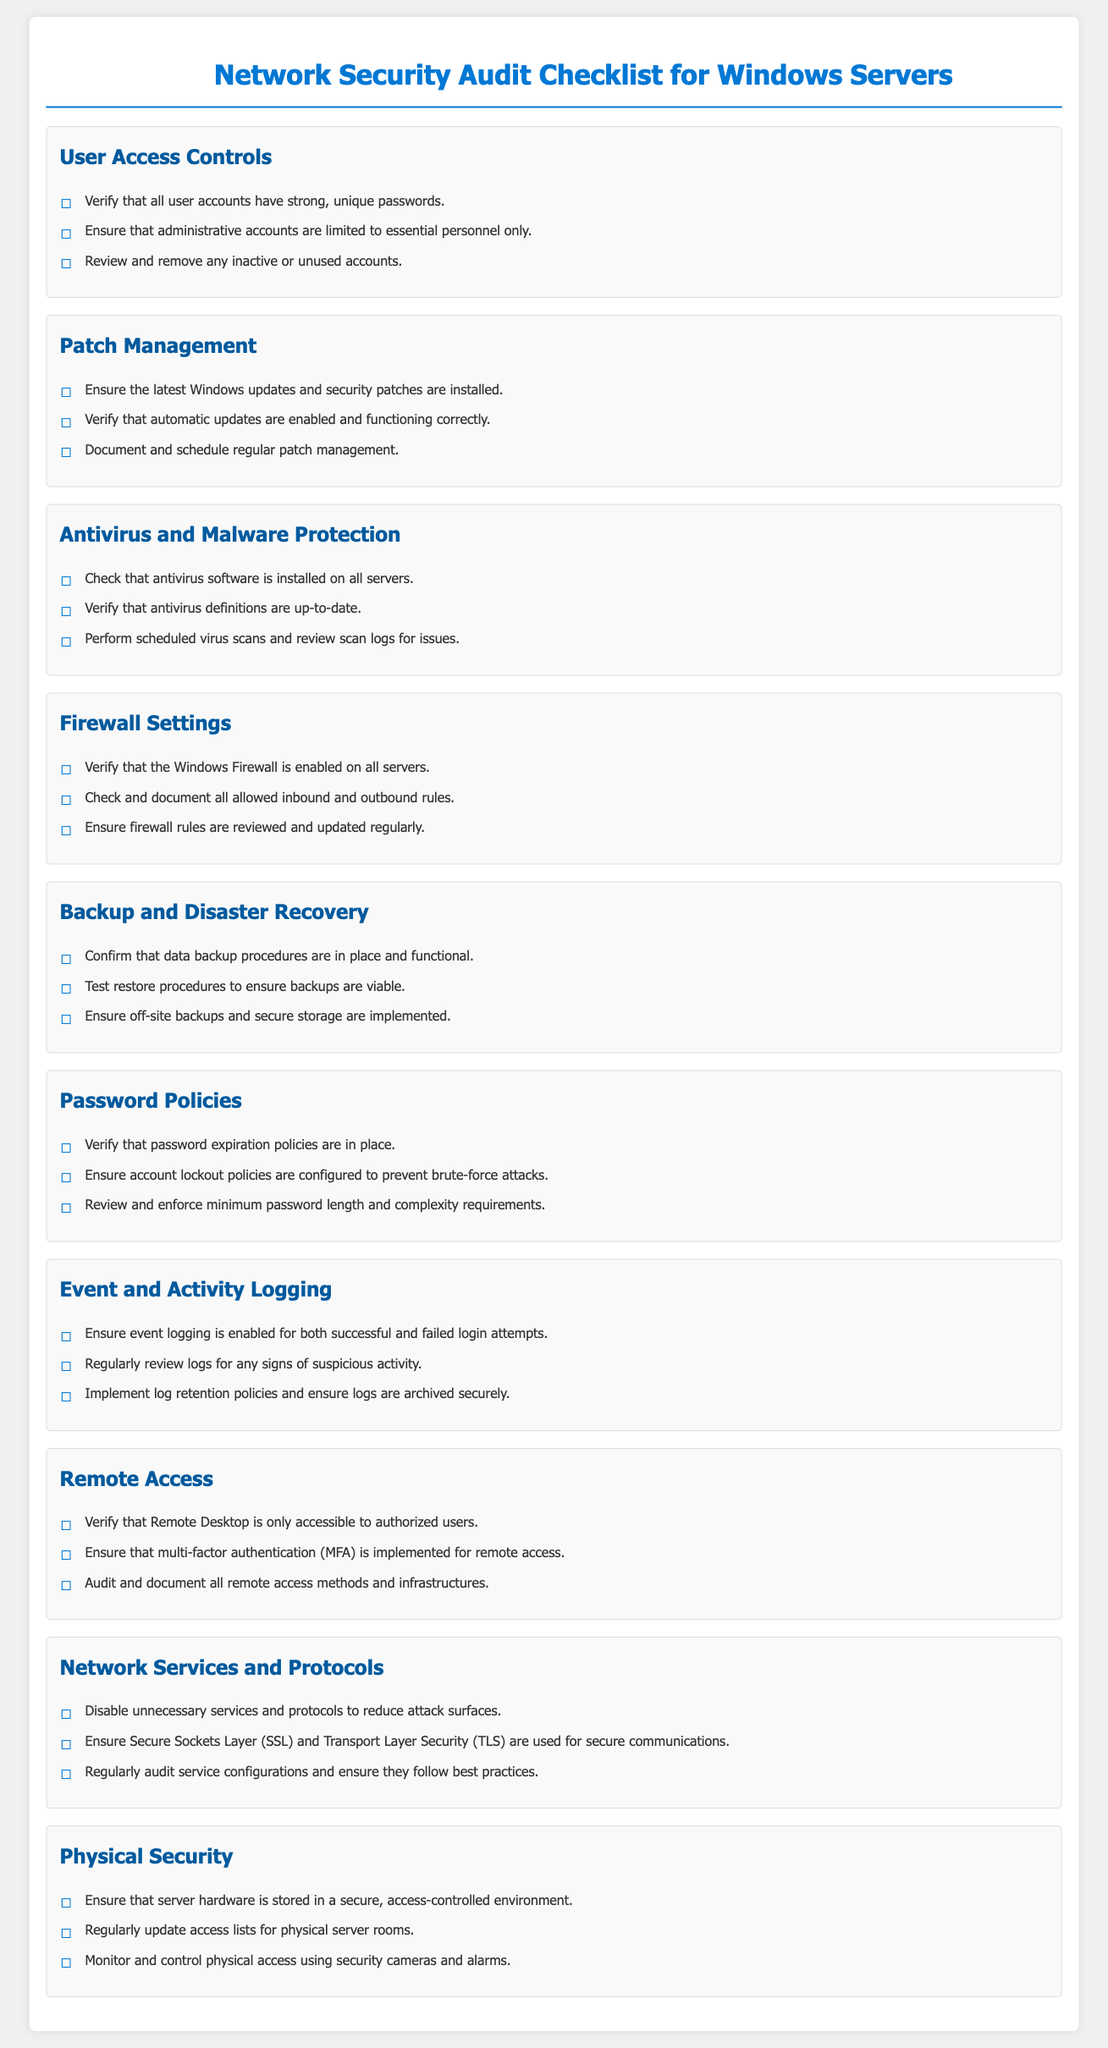What is the title of the document? The title of the document is located at the top of the rendered document, which identifies its purpose.
Answer: Network Security Audit Checklist for Windows Servers How many sections are listed in the document? The total count of distinct sections present in the document indicates the various aspects covered.
Answer: 10 What is one of the requirements for user access controls? The specific requirements for user access controls are contained within the subsection details.
Answer: Strong, unique passwords What must be verified for antivirus and malware protection? This relates to the specific checks required for antivirus implementation mentioned in the relevant section.
Answer: Antivirus definitions are up-to-date What is one action to take for backup and disaster recovery? The actions related to data backup policies can be found within that specific section.
Answer: Test restore procedures What is emphasized for remote access? This question relates to the security measures needed when allowing remote access according to the checklist.
Answer: Multi-factor authentication How often should firewall rules be reviewed? The requirement regarding the frequency of firewall rule updates is mentioned in the firewall settings section.
Answer: Regularly Where should server hardware be stored according to physical security measures? The details regarding the physical security of server locations can be found in that respective section.
Answer: Secure, access-controlled environment What should event logging capture according to the checklist? The details on logging requirements can be found in the specified section on event and activity logging.
Answer: Successful and failed login attempts What type of services should be disabled to enhance security? The guidelines for network services are indicated in the section dedicated to network services and protocols.
Answer: Unnecessary services and protocols 